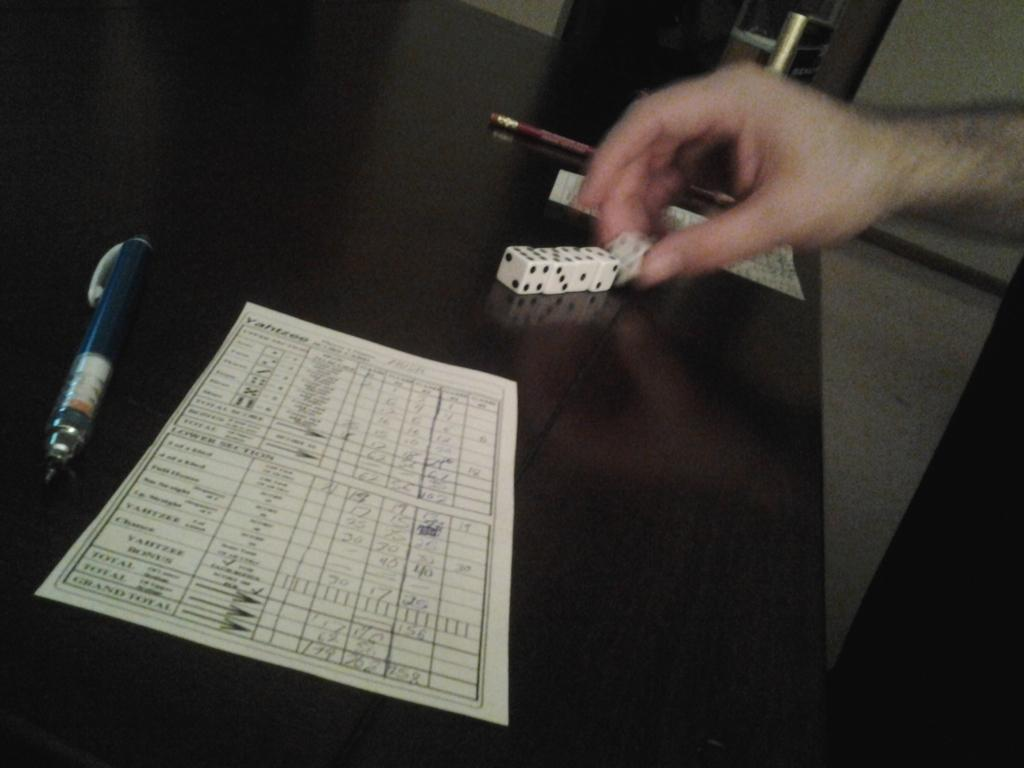What piece of furniture is in the image? There is a table in the image. What is on the table? A paper, a pen, a pencil, and dice are on the table. What is the person's hand doing in the image? The person's hand is holding a dice. What can be seen behind the table? There is a door visible behind the table. What type of authority figure is present in the image? There is no authority figure present in the image. How does the edge of the table contribute to the overall aesthetic of the image? The edge of the table is not mentioned in the provided facts, so it cannot be determined how it contributes to the overall aesthetic of the image. 